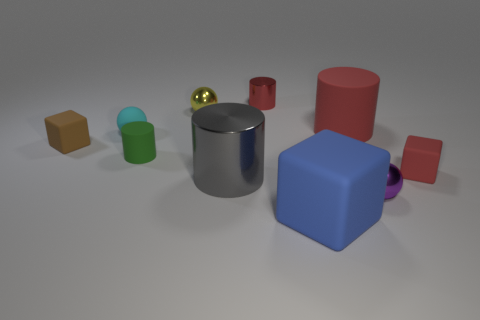Do the yellow shiny thing and the gray metallic cylinder have the same size?
Make the answer very short. No. There is a large thing that is both to the right of the gray shiny cylinder and in front of the large matte cylinder; what is its color?
Provide a short and direct response. Blue. There is a brown object that is made of the same material as the green thing; what shape is it?
Provide a succinct answer. Cube. How many metal things are behind the big matte cylinder and on the left side of the small metal cylinder?
Your response must be concise. 1. Are there any small rubber cylinders behind the small purple object?
Your answer should be very brief. Yes. There is a large red thing behind the cyan sphere; is its shape the same as the tiny red object that is behind the brown cube?
Keep it short and to the point. Yes. How many things are either large red matte cylinders or rubber blocks that are on the left side of the big red cylinder?
Your answer should be compact. 3. What number of other objects are there of the same shape as the yellow thing?
Your response must be concise. 2. Does the red cylinder in front of the yellow metal ball have the same material as the big gray thing?
Offer a terse response. No. What number of things are either green metallic cubes or large rubber blocks?
Provide a short and direct response. 1. 